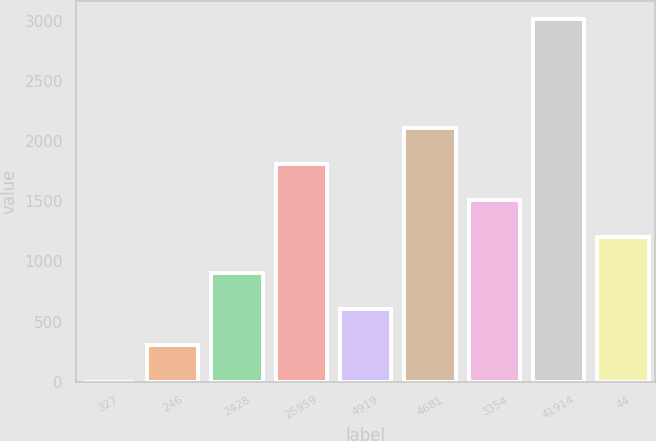Convert chart to OTSL. <chart><loc_0><loc_0><loc_500><loc_500><bar_chart><fcel>327<fcel>246<fcel>2428<fcel>25959<fcel>4919<fcel>4681<fcel>3354<fcel>41914<fcel>44<nl><fcel>0.5<fcel>301.91<fcel>904.73<fcel>1808.96<fcel>603.32<fcel>2110.37<fcel>1507.55<fcel>3014.6<fcel>1206.14<nl></chart> 